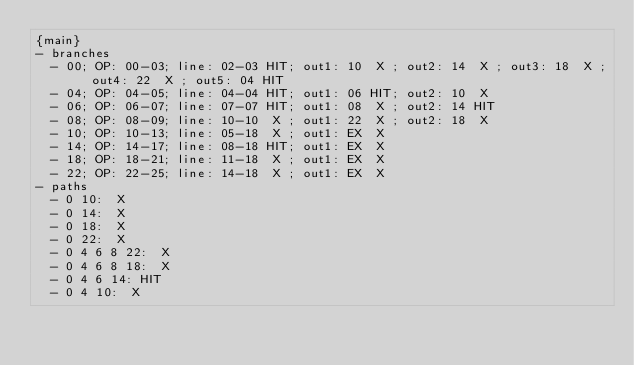<code> <loc_0><loc_0><loc_500><loc_500><_PHP_>{main}
- branches
  - 00; OP: 00-03; line: 02-03 HIT; out1: 10  X ; out2: 14  X ; out3: 18  X ; out4: 22  X ; out5: 04 HIT
  - 04; OP: 04-05; line: 04-04 HIT; out1: 06 HIT; out2: 10  X 
  - 06; OP: 06-07; line: 07-07 HIT; out1: 08  X ; out2: 14 HIT
  - 08; OP: 08-09; line: 10-10  X ; out1: 22  X ; out2: 18  X 
  - 10; OP: 10-13; line: 05-18  X ; out1: EX  X 
  - 14; OP: 14-17; line: 08-18 HIT; out1: EX  X 
  - 18; OP: 18-21; line: 11-18  X ; out1: EX  X 
  - 22; OP: 22-25; line: 14-18  X ; out1: EX  X 
- paths
  - 0 10:  X 
  - 0 14:  X 
  - 0 18:  X 
  - 0 22:  X 
  - 0 4 6 8 22:  X 
  - 0 4 6 8 18:  X 
  - 0 4 6 14: HIT
  - 0 4 10:  X
</code> 